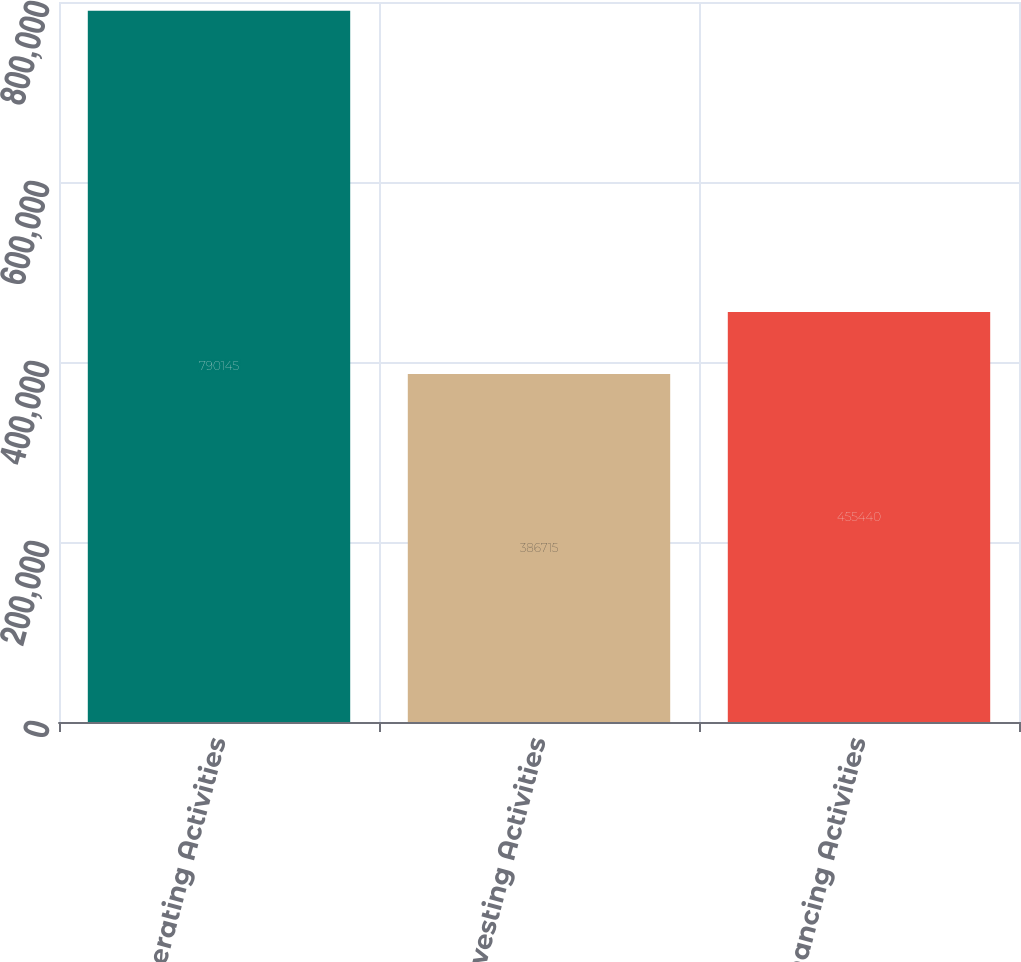Convert chart to OTSL. <chart><loc_0><loc_0><loc_500><loc_500><bar_chart><fcel>Operating Activities<fcel>Investing Activities<fcel>Financing Activities<nl><fcel>790145<fcel>386715<fcel>455440<nl></chart> 